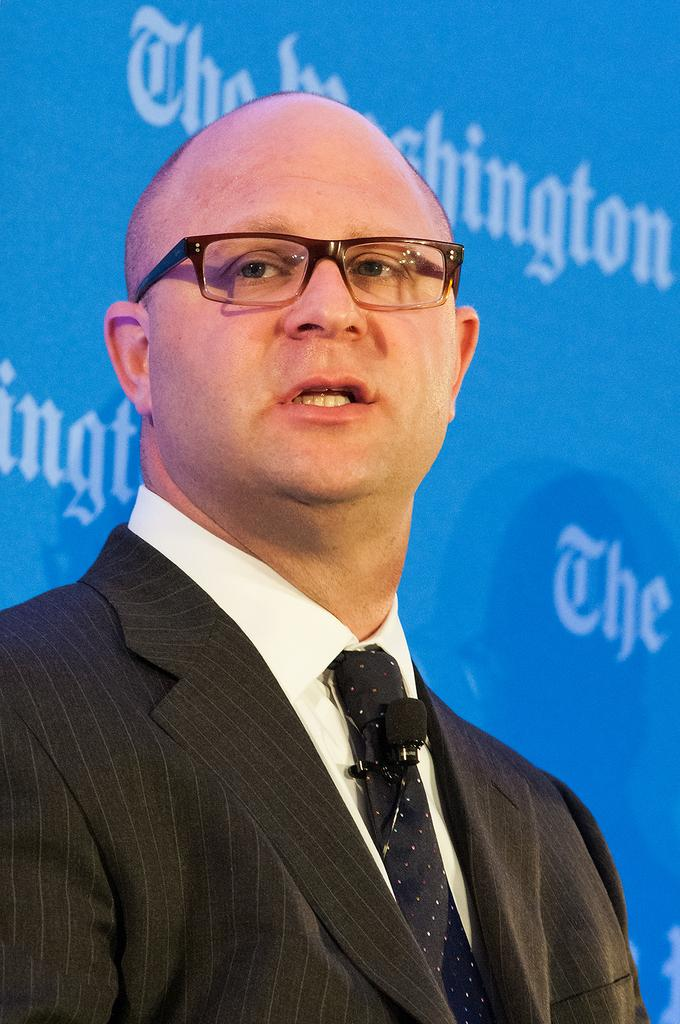What is the main subject of the image? The main subject of the image is a man. What is the man wearing in the image? The man is wearing a blazer and a tie in the image. What is the man holding in the image? The man is holding a mic in the image. What accessory is the man wearing in the image? The man is wearing spectacles in the image. What can be seen in the background of the image? There is a banner in the background of the image. How many chickens are visible in the image? There are no chickens present in the image. What type of fang can be seen on the man's face in the image? There is no fang present on the man's face in the image. 